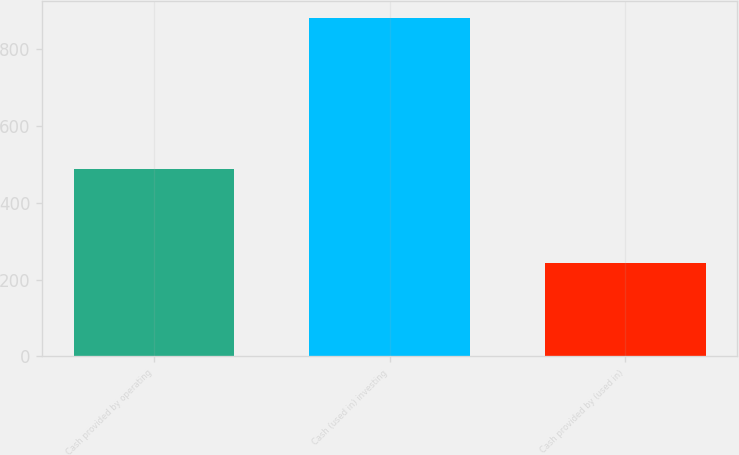Convert chart to OTSL. <chart><loc_0><loc_0><loc_500><loc_500><bar_chart><fcel>Cash provided by operating<fcel>Cash (used in) investing<fcel>Cash provided by (used in)<nl><fcel>486.1<fcel>879.1<fcel>243.5<nl></chart> 